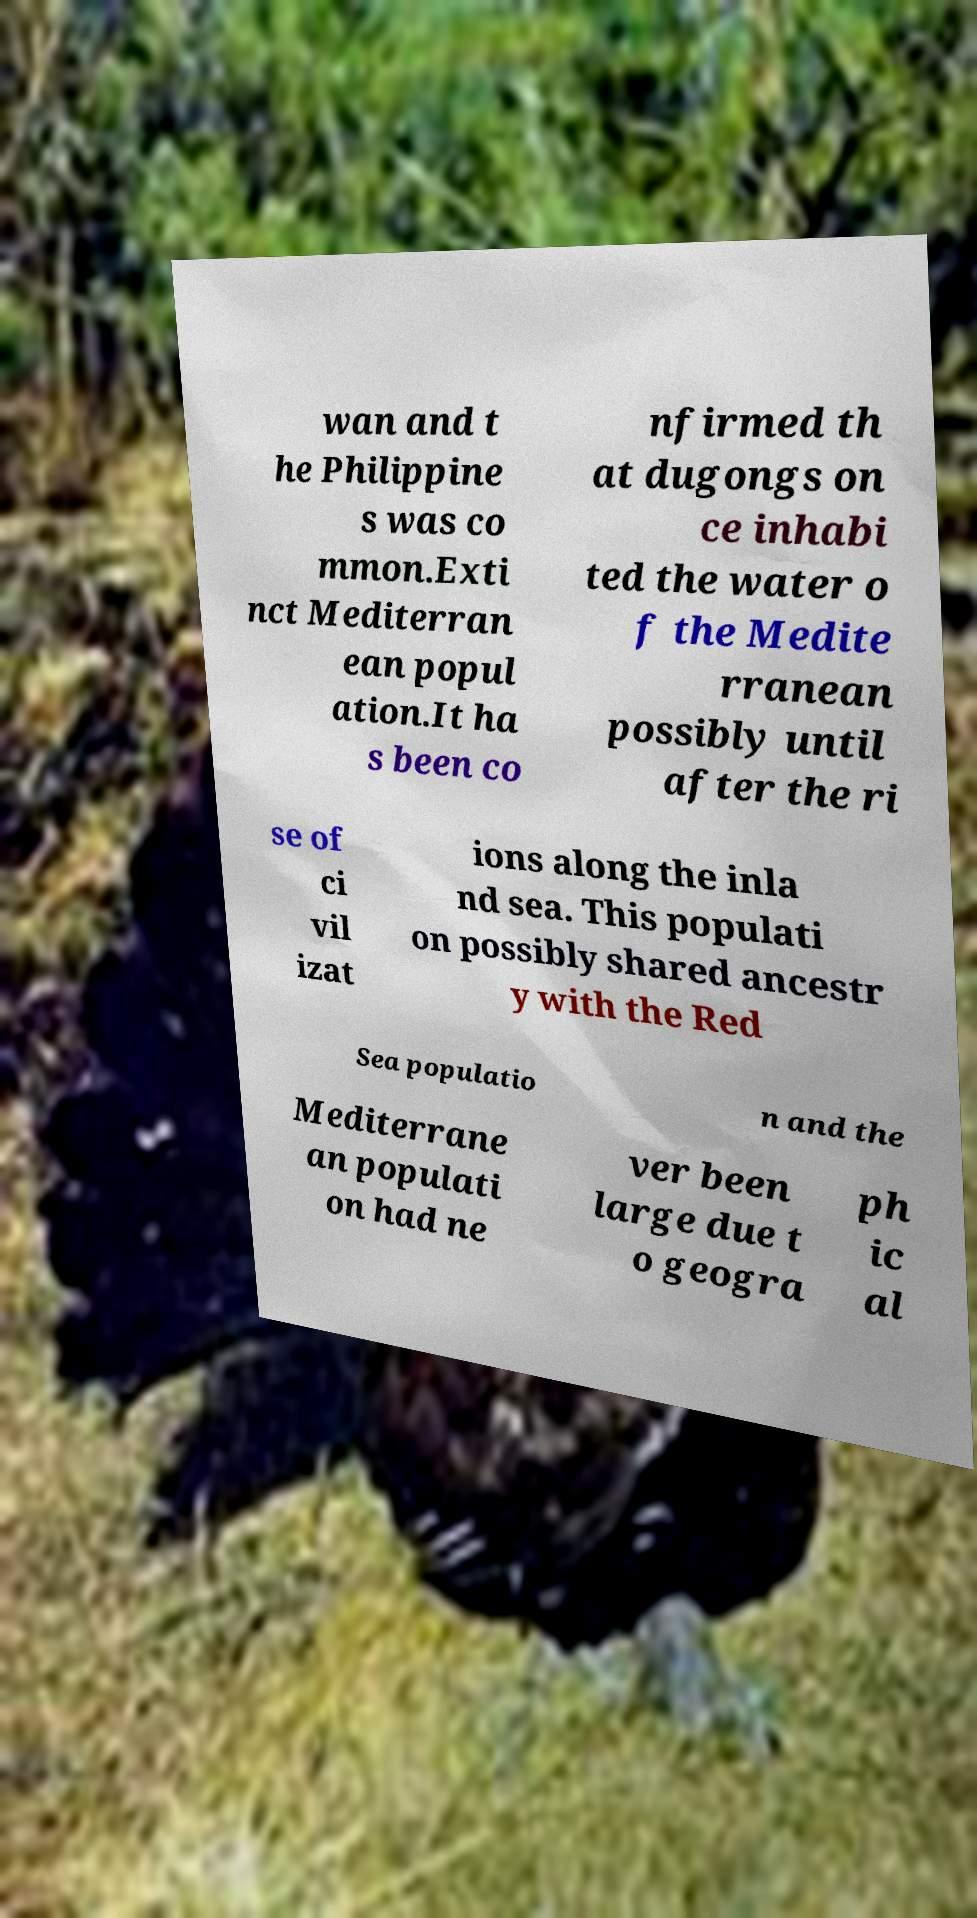Please read and relay the text visible in this image. What does it say? wan and t he Philippine s was co mmon.Exti nct Mediterran ean popul ation.It ha s been co nfirmed th at dugongs on ce inhabi ted the water o f the Medite rranean possibly until after the ri se of ci vil izat ions along the inla nd sea. This populati on possibly shared ancestr y with the Red Sea populatio n and the Mediterrane an populati on had ne ver been large due t o geogra ph ic al 